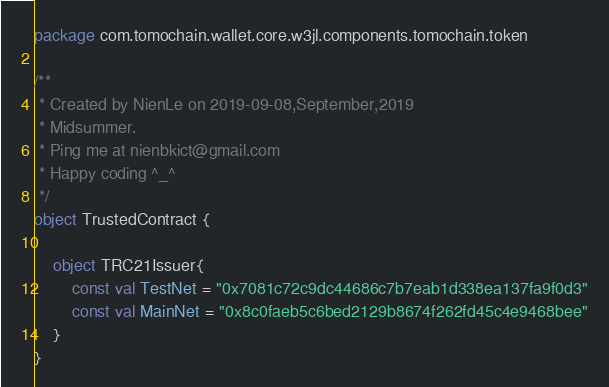<code> <loc_0><loc_0><loc_500><loc_500><_Kotlin_>package com.tomochain.wallet.core.w3jl.components.tomochain.token

/**
 * Created by NienLe on 2019-09-08,September,2019
 * Midsummer.
 * Ping me at nienbkict@gmail.com
 * Happy coding ^_^
 */
object TrustedContract {

    object TRC21Issuer{
        const val TestNet = "0x7081c72c9dc44686c7b7eab1d338ea137fa9f0d3"
        const val MainNet = "0x8c0faeb5c6bed2129b8674f262fd45c4e9468bee"
    }
}</code> 